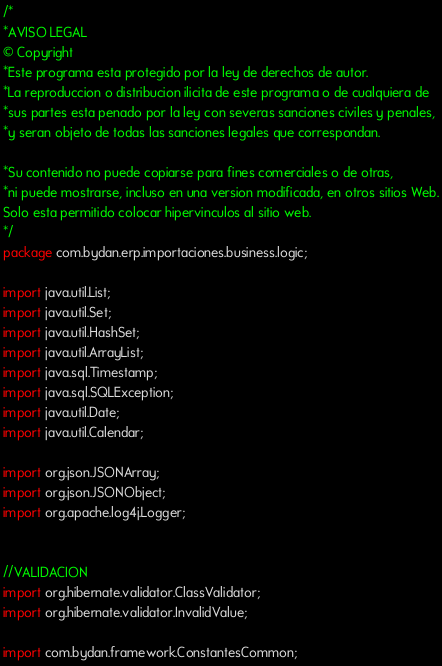Convert code to text. <code><loc_0><loc_0><loc_500><loc_500><_Java_>/*
*AVISO LEGAL
© Copyright
*Este programa esta protegido por la ley de derechos de autor.
*La reproduccion o distribucion ilicita de este programa o de cualquiera de
*sus partes esta penado por la ley con severas sanciones civiles y penales,
*y seran objeto de todas las sanciones legales que correspondan.

*Su contenido no puede copiarse para fines comerciales o de otras,
*ni puede mostrarse, incluso en una version modificada, en otros sitios Web.
Solo esta permitido colocar hipervinculos al sitio web.
*/
package com.bydan.erp.importaciones.business.logic;

import java.util.List;
import java.util.Set;
import java.util.HashSet;
import java.util.ArrayList;
import java.sql.Timestamp;
import java.sql.SQLException;
import java.util.Date;
import java.util.Calendar;

import org.json.JSONArray;
import org.json.JSONObject;
import org.apache.log4j.Logger;


//VALIDACION
import org.hibernate.validator.ClassValidator;
import org.hibernate.validator.InvalidValue;

import com.bydan.framework.ConstantesCommon;</code> 